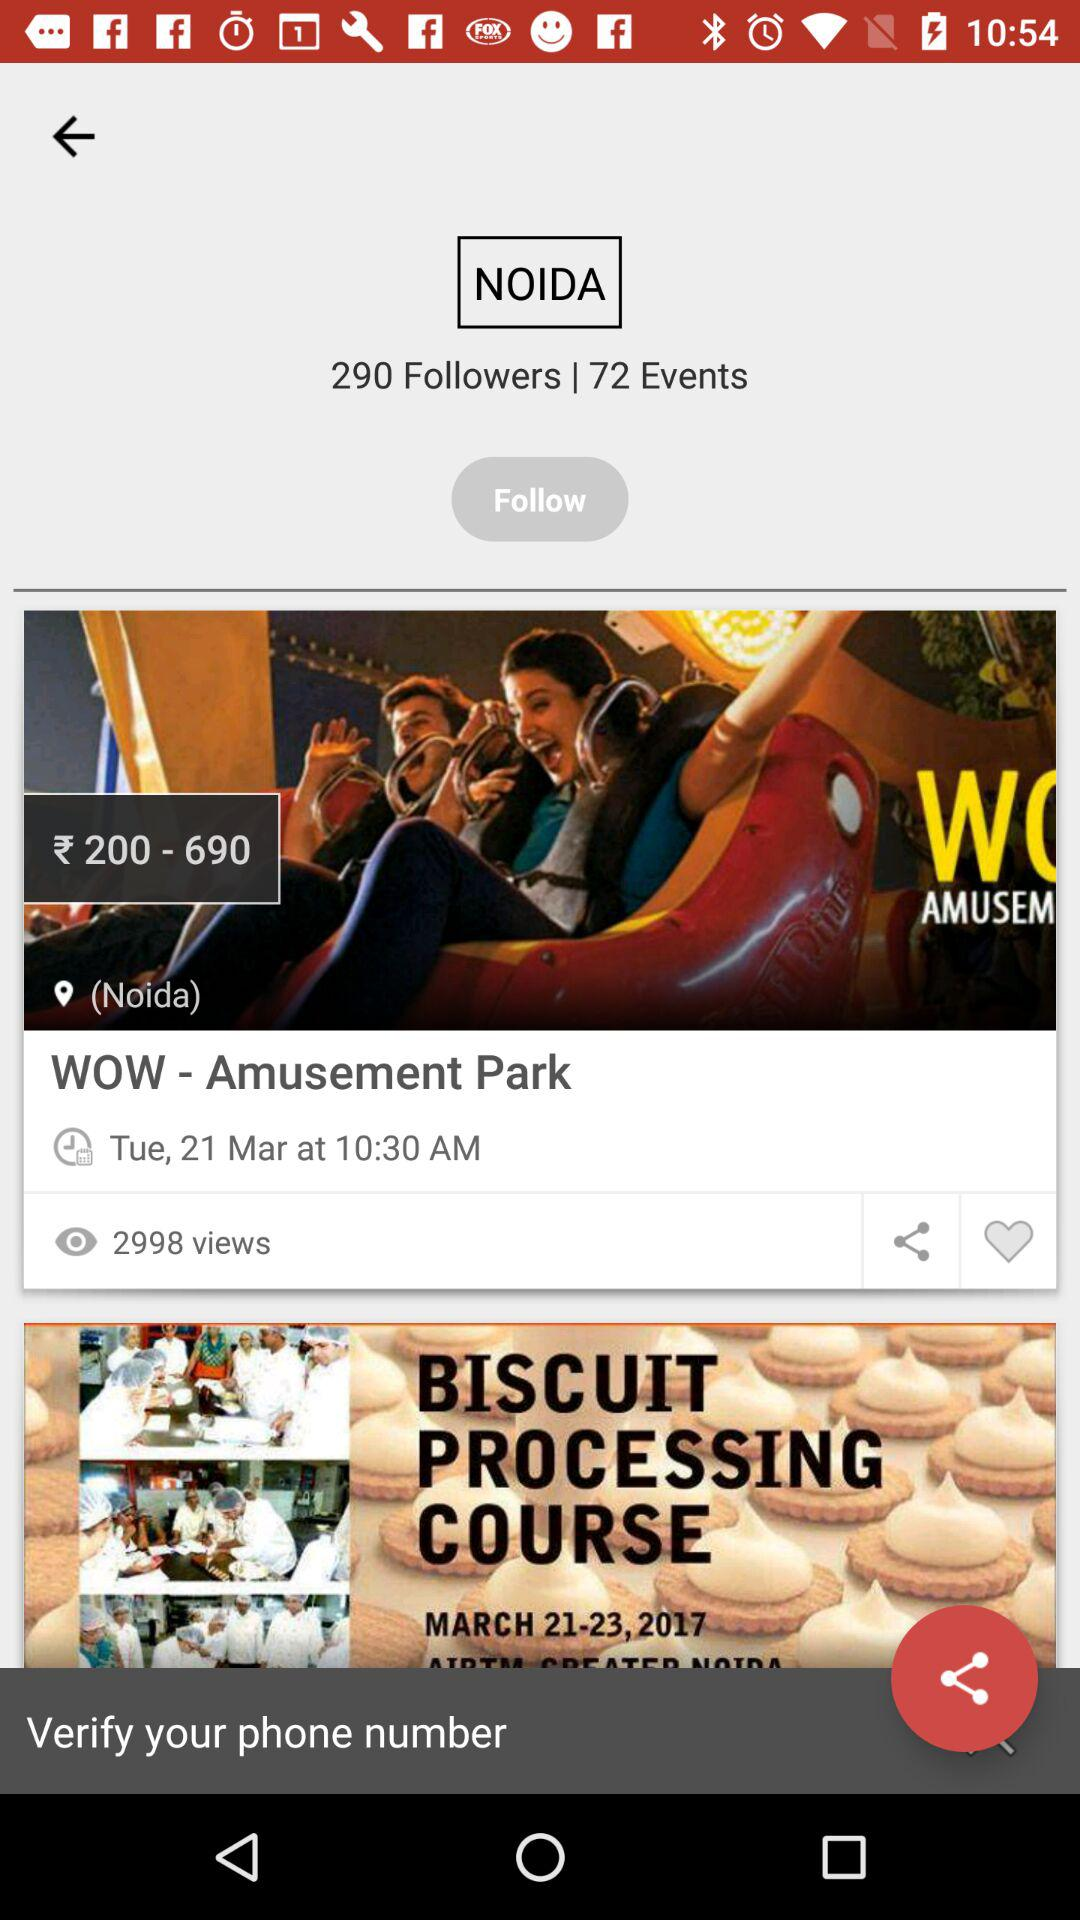How many people have viewed "WOW - Amusement Park"? "WOW - Amusement Park" has been viewed by 2998 people. 